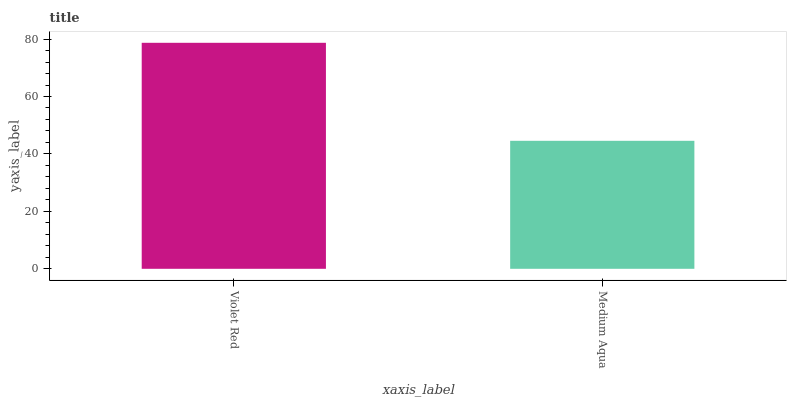Is Medium Aqua the minimum?
Answer yes or no. Yes. Is Violet Red the maximum?
Answer yes or no. Yes. Is Medium Aqua the maximum?
Answer yes or no. No. Is Violet Red greater than Medium Aqua?
Answer yes or no. Yes. Is Medium Aqua less than Violet Red?
Answer yes or no. Yes. Is Medium Aqua greater than Violet Red?
Answer yes or no. No. Is Violet Red less than Medium Aqua?
Answer yes or no. No. Is Violet Red the high median?
Answer yes or no. Yes. Is Medium Aqua the low median?
Answer yes or no. Yes. Is Medium Aqua the high median?
Answer yes or no. No. Is Violet Red the low median?
Answer yes or no. No. 